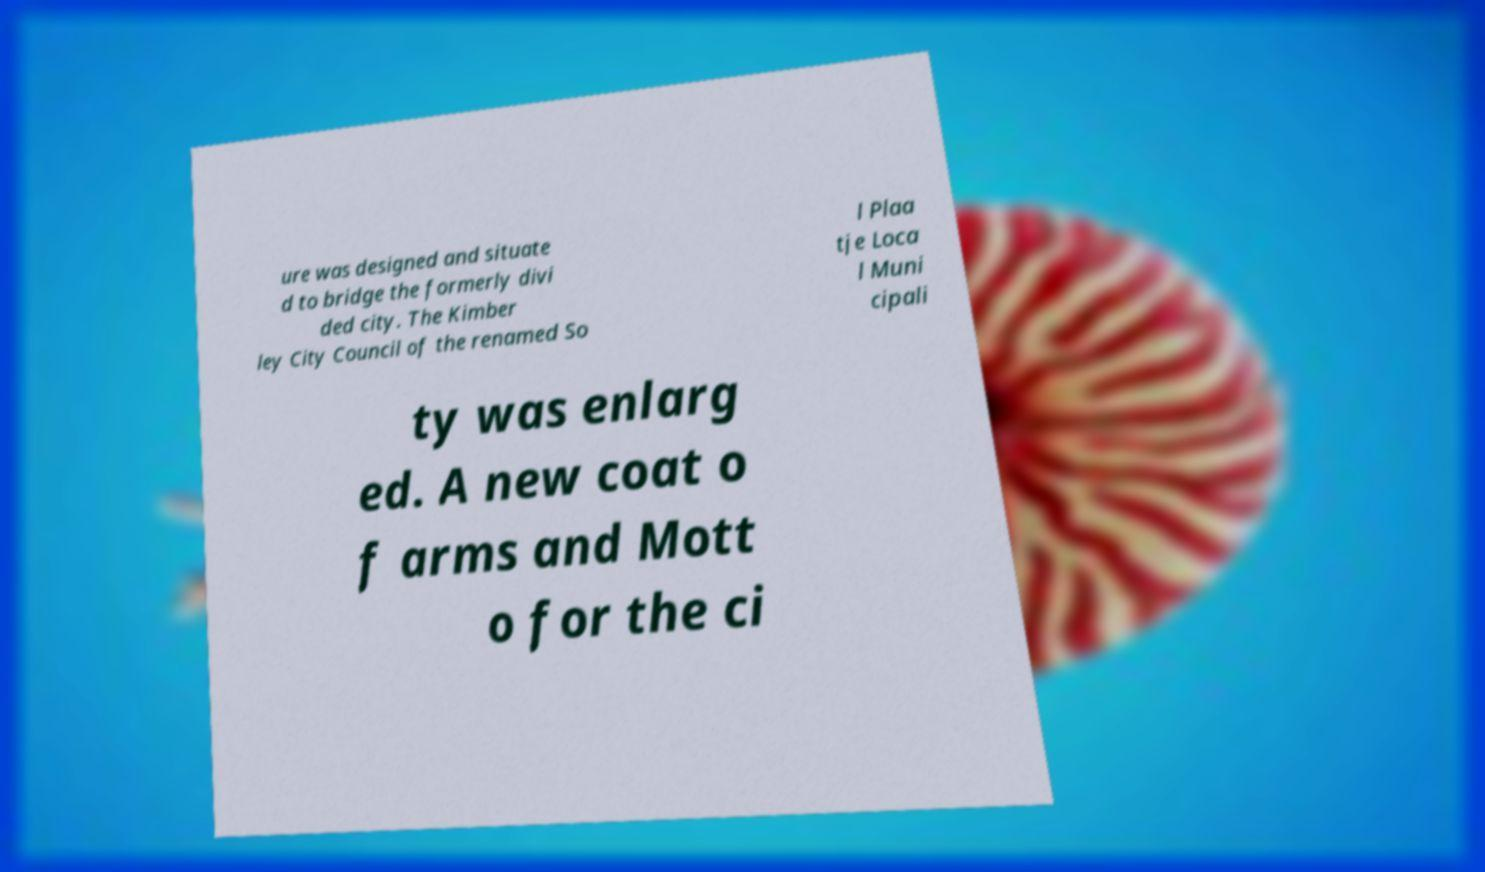Could you extract and type out the text from this image? ure was designed and situate d to bridge the formerly divi ded city. The Kimber ley City Council of the renamed So l Plaa tje Loca l Muni cipali ty was enlarg ed. A new coat o f arms and Mott o for the ci 